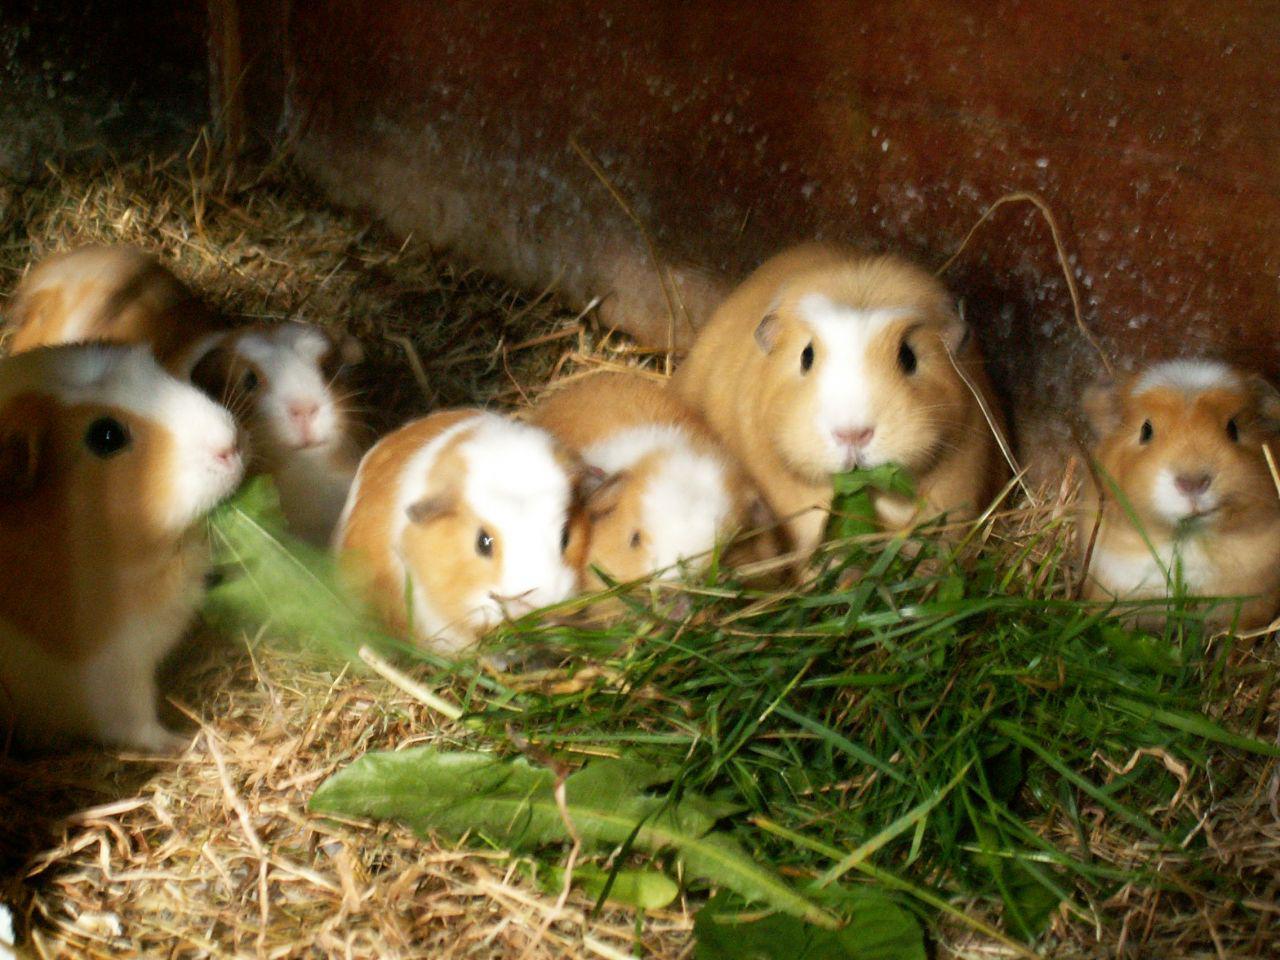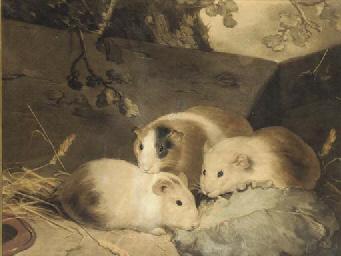The first image is the image on the left, the second image is the image on the right. Considering the images on both sides, is "Left image shows tan and white hamsters with green leafy items to eat in front of them." valid? Answer yes or no. Yes. The first image is the image on the left, the second image is the image on the right. Considering the images on both sides, is "There are exactly six guinea pigs in the left image and some of them are eating." valid? Answer yes or no. Yes. 